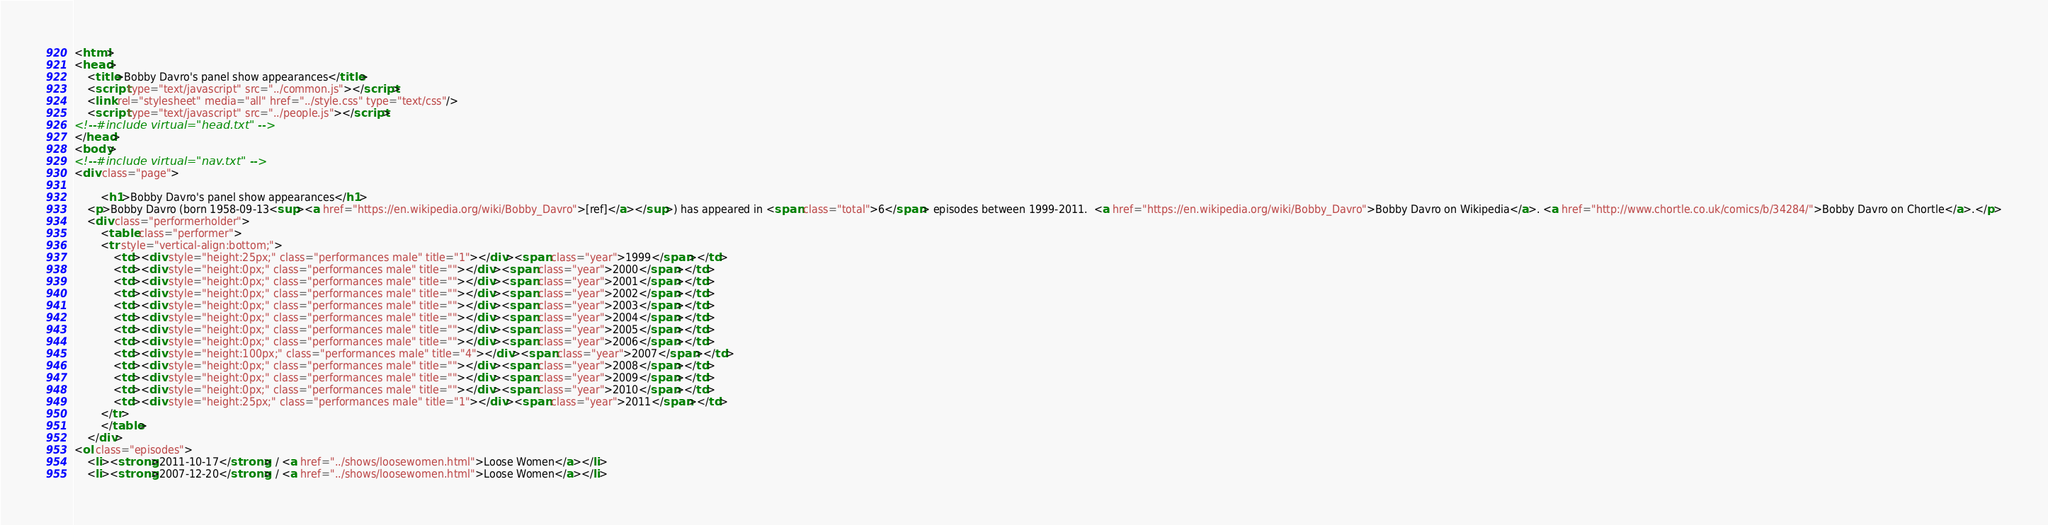Convert code to text. <code><loc_0><loc_0><loc_500><loc_500><_HTML_><html>
<head>
	<title>Bobby Davro's panel show appearances</title>
	<script type="text/javascript" src="../common.js"></script>
	<link rel="stylesheet" media="all" href="../style.css" type="text/css"/>
	<script type="text/javascript" src="../people.js"></script>
<!--#include virtual="head.txt" -->
</head>
<body>
<!--#include virtual="nav.txt" -->
<div class="page">

		<h1>Bobby Davro's panel show appearances</h1>
	<p>Bobby Davro (born 1958-09-13<sup><a href="https://en.wikipedia.org/wiki/Bobby_Davro">[ref]</a></sup>) has appeared in <span class="total">6</span> episodes between 1999-2011.  <a href="https://en.wikipedia.org/wiki/Bobby_Davro">Bobby Davro on Wikipedia</a>. <a href="http://www.chortle.co.uk/comics/b/34284/">Bobby Davro on Chortle</a>.</p>
	<div class="performerholder">
		<table class="performer">
		<tr style="vertical-align:bottom;">
			<td><div style="height:25px;" class="performances male" title="1"></div><span class="year">1999</span></td>
			<td><div style="height:0px;" class="performances male" title=""></div><span class="year">2000</span></td>
			<td><div style="height:0px;" class="performances male" title=""></div><span class="year">2001</span></td>
			<td><div style="height:0px;" class="performances male" title=""></div><span class="year">2002</span></td>
			<td><div style="height:0px;" class="performances male" title=""></div><span class="year">2003</span></td>
			<td><div style="height:0px;" class="performances male" title=""></div><span class="year">2004</span></td>
			<td><div style="height:0px;" class="performances male" title=""></div><span class="year">2005</span></td>
			<td><div style="height:0px;" class="performances male" title=""></div><span class="year">2006</span></td>
			<td><div style="height:100px;" class="performances male" title="4"></div><span class="year">2007</span></td>
			<td><div style="height:0px;" class="performances male" title=""></div><span class="year">2008</span></td>
			<td><div style="height:0px;" class="performances male" title=""></div><span class="year">2009</span></td>
			<td><div style="height:0px;" class="performances male" title=""></div><span class="year">2010</span></td>
			<td><div style="height:25px;" class="performances male" title="1"></div><span class="year">2011</span></td>
		</tr>
		</table>
	</div>
<ol class="episodes">
	<li><strong>2011-10-17</strong> / <a href="../shows/loosewomen.html">Loose Women</a></li>
	<li><strong>2007-12-20</strong> / <a href="../shows/loosewomen.html">Loose Women</a></li></code> 